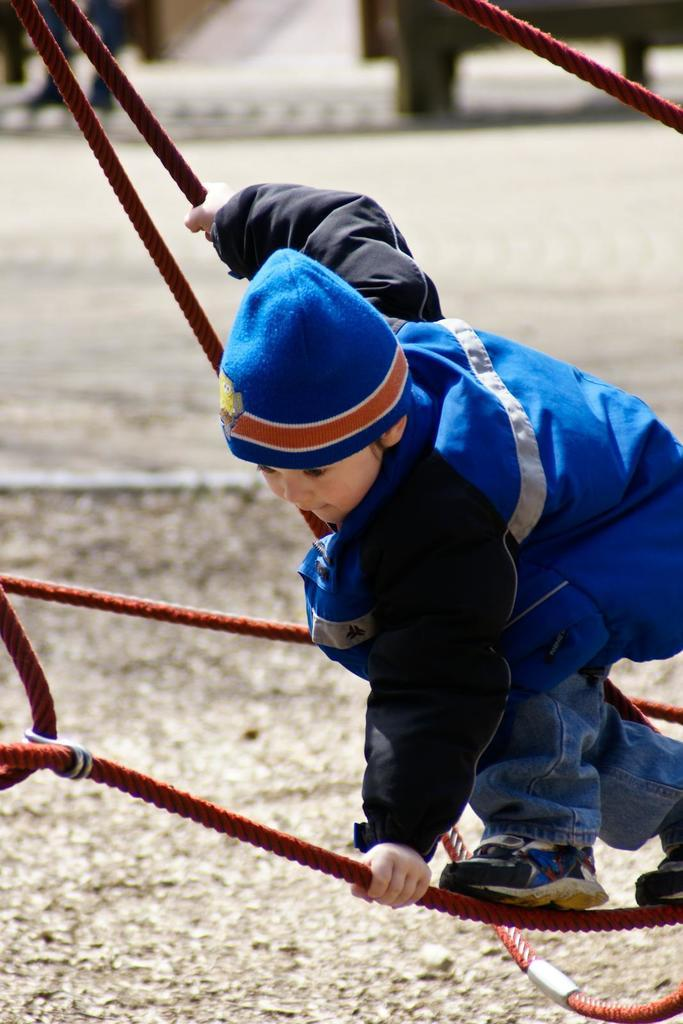Who is the main subject in the image? There is a boy in the image. What is the boy doing in the image? The boy is standing on a rope and holding a rope. What can be seen at the bottom of the image? There is a road visible at the bottom of the image. How many cents are visible in the image? There are no cents present in the image. Is there a visitor in the image? The image does not show any visitors; it only features the boy standing on a rope. 